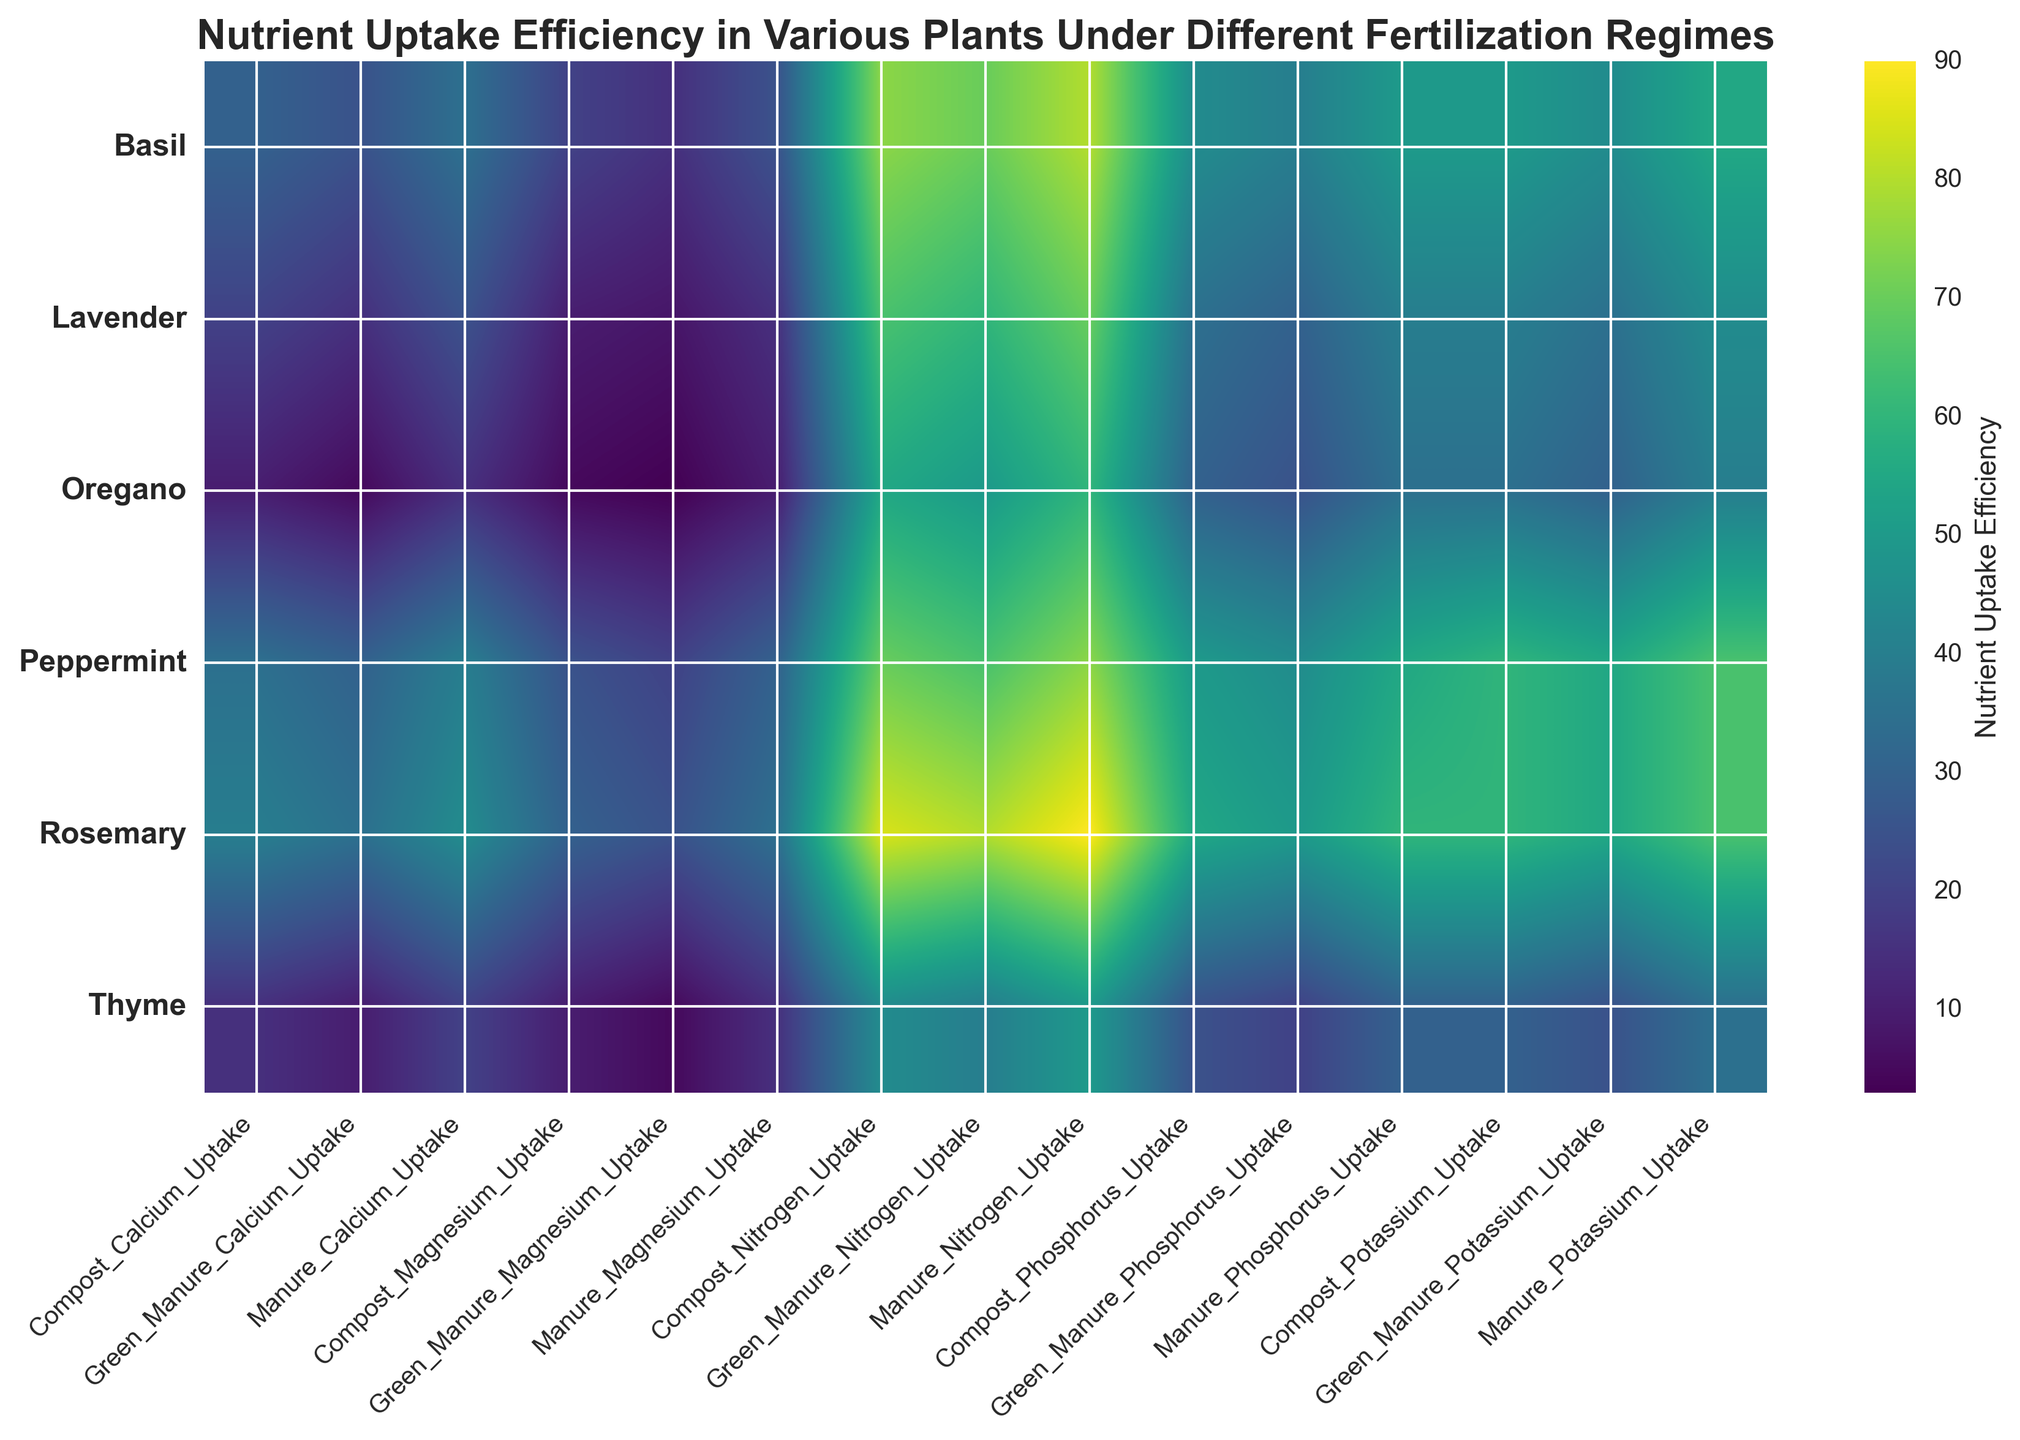What's the average Nitrogen Uptake efficiency for Rosemary across all fertilization types? To find the average Nitrogen Uptake efficiency for Rosemary, sum the Nitrogen Uptake values for Rosemary across all fertilization types (85 for Compost, 90 for Manure, and 80 for Green Manure), and then divide by the number of fertilization types (3). The calculation is (85 + 90 + 80) / 3 = 85.
Answer: 85 Which plant shows the highest Magnesium Uptake when Manure is used as the fertilizer? To determine this, find the Magnesium Uptake values for all plants where the fertilizer type is Manure and compare them. The values are 25 for Basil, 15 for Lavender, 35 for Rosemary, 10 for Oregano, 15 for Thyme, and 30 for Peppermint. The highest value is 35 for Rosemary.
Answer: Rosemary Under which fertilization regime does Peppermint have the highest Phosphorus Uptake efficiency? Look at the Phosphorus Uptake values for Peppermint under different fertilization regimes: Compost (50), Manure (55), and Green Manure (45). The highest value is 55 under Manure.
Answer: Manure When comparing Compost and Green Manure, which fertilization type results in higher average Calcium Uptake efficiency across all plants? First, calculate the average Calcium Uptake for Compost and Green Manure across all plants. For Compost: (30 + 20 + 40 + 10 + 15 + 35) / 6 = 25. For Green Manure: (25 + 15 + 35 + 5 + 10 + 30) / 6 ≈ 20.83. Compost has a higher average Calcium Uptake efficiency.
Answer: Compost Which plant-fertilizer combination has the lowest Potassium Uptake efficiency? Review the Potassium Uptake values for each plant under each fertilization regime to find the lowest value. The lowest value is 25, for Thyme under Green Manure.
Answer: Thyme with Green Manure How does the Nitrogen Uptake efficiency of Manure compare between Basil and Peppermint? Check the Nitrogen Uptake values for Basil and Peppermint under Manure. Basil has a value of 80, and Peppermint has a value of 75. Therefore, Basil has a higher Nitrogen Uptake efficiency than Peppermint under Manure.
Answer: Basil higher than Peppermint What's the total Phosphorus Uptake for Oregano across all fertilization types? Sum the Phosphorus Uptake values for Oregano: 30 for Compost, 35 for Manure, and 25 for Green Manure. The total is 30 + 35 + 25 = 90.
Answer: 90 Which plant shows the most variation in Potassium Uptake across different fertilization regimes? Calculate the range (difference between the highest and lowest values) of Potassium Uptake for each plant. The ranges are:
- Basil: 55 - 45 = 10
- Lavender: 45 - 35 = 10
- Rosemary: 65 - 55 = 10
- Oregano: 40 - 30 = 10
- Thyme: 35 - 25 = 10
- Peppermint: 65 - 55 = 10
All ranges are the same (10). Therefore, all plants exhibit the same variation in Potassium Uptake.
Answer: All plants the same What is the average Magnesium Uptake efficiency for all plants under Green Manure? Sum the Magnesium Uptake values for all plants under Green Manure (15 for Basil, 8 for Lavender, 25 for Rosemary, 3 for Oregano, 5 for Thyme, and 20 for Peppermint), and then divide by the number of plants (6). The calculation is (15 + 8 + 25 + 3 + 5 + 20) / 6 ≈ 12.67.
Answer: 12.67 